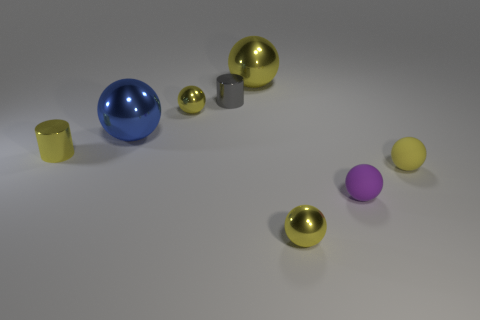There is another cylinder that is the same material as the tiny gray cylinder; what size is it?
Make the answer very short. Small. What is the yellow ball that is in front of the purple thing made of?
Your answer should be compact. Metal. How many gray metal objects are the same shape as the tiny purple object?
Offer a very short reply. 0. What is the tiny yellow sphere that is left of the small yellow metallic ball that is in front of the yellow matte object made of?
Your answer should be compact. Metal. What size is the metallic sphere that is behind the small gray cylinder?
Ensure brevity in your answer.  Large. What number of brown things are small metallic objects or rubber objects?
Make the answer very short. 0. There is a yellow thing that is the same shape as the small gray object; what is it made of?
Give a very brief answer. Metal. Are there an equal number of blue shiny things in front of the purple object and large red matte balls?
Ensure brevity in your answer.  Yes. What is the size of the yellow thing that is both right of the small gray object and behind the blue metal ball?
Your answer should be compact. Large. What size is the blue metallic object that is to the left of the rubber object behind the small purple matte ball?
Give a very brief answer. Large. 